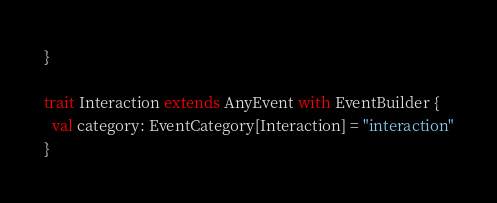<code> <loc_0><loc_0><loc_500><loc_500><_Scala_>}

trait Interaction extends AnyEvent with EventBuilder {
  val category: EventCategory[Interaction] = "interaction"
}
</code> 